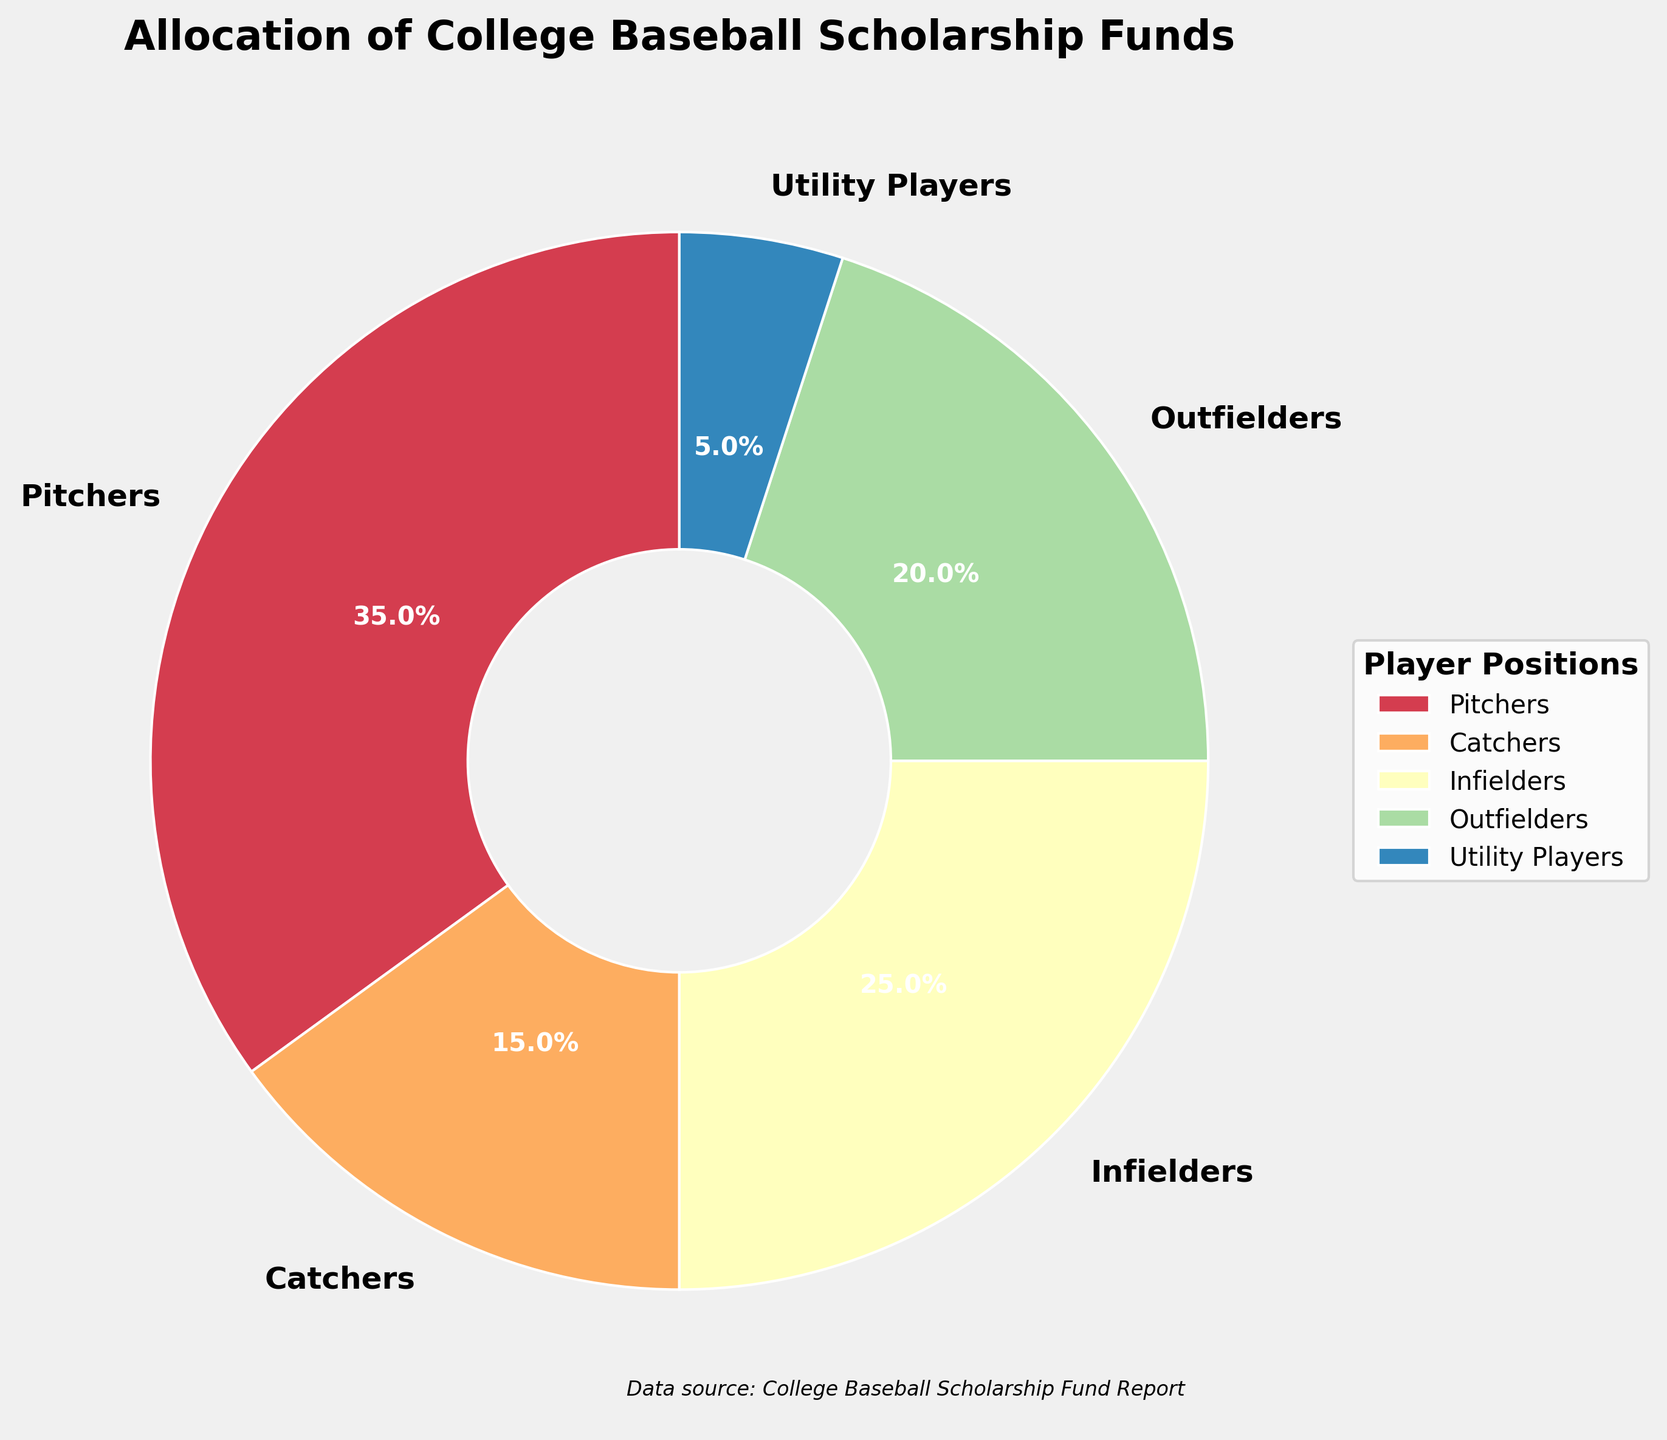What position receives the largest percentage of scholarship funds? Looking at the pie chart, the largest section corresponds to Pitchers. The label shows that Pitchers receive 35% of the scholarship funds.
Answer: Pitchers What positions receive an equal percentage of scholarship funds? By observing the percentages next to each labeled section, no two positions receive an equal percentage of scholarship funds.
Answer: None What is the combined percentage of scholarship funds allocated to Infielders and Outfielders? The pie chart shows Infielders receive 25% and Outfielders receive 20%. Adding these percentages gives the combined percentage: 25% + 20% = 45%.
Answer: 45% How does the scholarship percentage for Utility Players compare to that of Catchers? Utility Players receive 5% of the scholarship funds while Catchers receive 15%. Therefore, the percentage for Utility Players is less than that for Catchers.
Answer: Less than Is the percentage of scholarship funds for Pitchers greater than the combined funds for Utility Players and Catchers? The percentage for Pitchers is 35%. The combined funds for Utility Players (5%) and Catchers (15%) is 5% + 15% = 20%. Since 35% > 20%, the percentage for Pitchers is indeed greater.
Answer: Yes What is the total percentage allotted to non-pitcher positions? The pie chart shows the following percentages for non-pitcher positions: Catchers (15%), Infielders (25%), Outfielders (20%), and Utility Players (5%). Adding these up: 15% + 25% + 20% + 5% = 65%.
Answer: 65% If an additional 10% of the funds were allocated to Utility Players, how would that compare to the funds for Outfielders? Utility Players currently receive 5%. Adding 10% would give them 5% + 10% = 15%. The Outfielders receive 20%, so 15% is still less than 20%.
Answer: Less than Which position receives the least amount of scholarship funds? Observing the smallest section in the pie chart, Utility Players have the least amount allocated, which is 5%.
Answer: Utility Players How much more percentage do Infielders receive compared to Catchers? Infielders receive 25% and Catchers receive 15%. The difference is 25% - 15% = 10%.
Answer: 10% What fraction of the total scholarship funds is allocated to Pitchers? Pitchers receive 35% of the scholarship funds. Converting this to a fraction: 35/100 = 7/20.
Answer: 7/20 